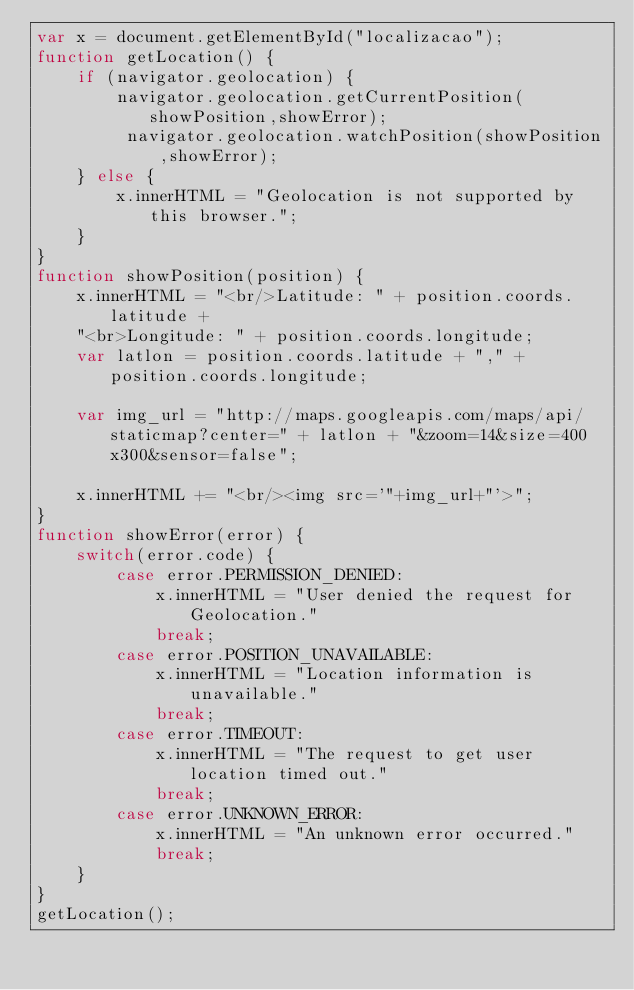Convert code to text. <code><loc_0><loc_0><loc_500><loc_500><_JavaScript_>var x = document.getElementById("localizacao");
function getLocation() {
    if (navigator.geolocation) {
        navigator.geolocation.getCurrentPosition(showPosition,showError);
         navigator.geolocation.watchPosition(showPosition,showError);
    } else {
        x.innerHTML = "Geolocation is not supported by this browser.";
    }
}
function showPosition(position) {
    x.innerHTML = "<br/>Latitude: " + position.coords.latitude + 
    "<br>Longitude: " + position.coords.longitude; 
    var latlon = position.coords.latitude + "," + position.coords.longitude;

    var img_url = "http://maps.googleapis.com/maps/api/staticmap?center=" + latlon + "&zoom=14&size=400x300&sensor=false";

    x.innerHTML += "<br/><img src='"+img_url+"'>";
}
function showError(error) {
    switch(error.code) {
        case error.PERMISSION_DENIED:
            x.innerHTML = "User denied the request for Geolocation."
            break;
        case error.POSITION_UNAVAILABLE:
            x.innerHTML = "Location information is unavailable."
            break;
        case error.TIMEOUT:
            x.innerHTML = "The request to get user location timed out."
            break;
        case error.UNKNOWN_ERROR:
            x.innerHTML = "An unknown error occurred."
            break;
    }
}
getLocation();</code> 